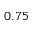<formula> <loc_0><loc_0><loc_500><loc_500>0 . 7 5</formula> 